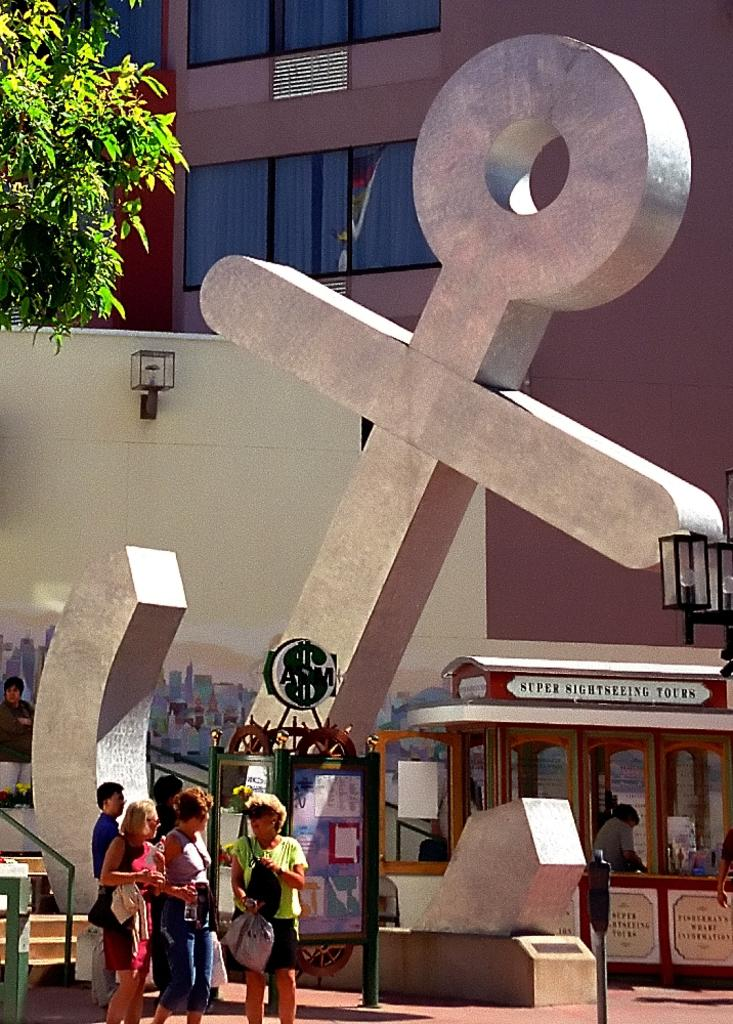What is the main subject of the image? The main subject of the image is an anchor-shaped statue. Can you describe the people in the image? There is a group of people in the image. What can be seen illuminated in the image? There are lights visible in the image. What type of vehicle is present in the image? There is a vehicle in the image. What is the closest structure to the statue? There is a wall in the image. What type of plant is visible in the image? There is a tree in the image. What can be seen in the background of the image? There is a building in the background of the image. What type of celery dish is being served for dinner in the image? There is no celery dish or dinner present in the image. How does the statue burn in the image? The statue does not burn in the image; it is a stationary object made of a non-flammable material. 